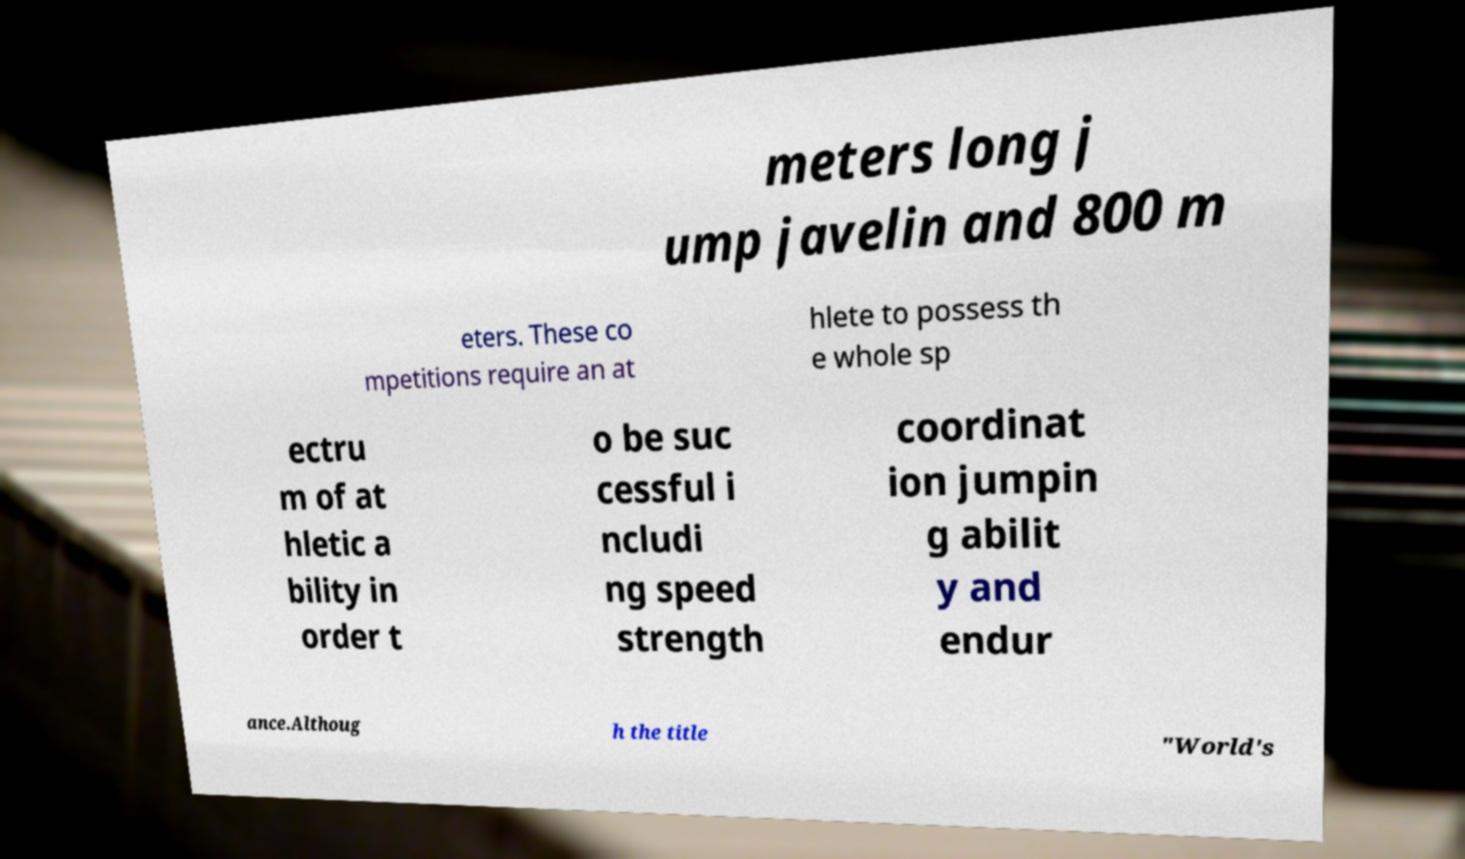Please read and relay the text visible in this image. What does it say? meters long j ump javelin and 800 m eters. These co mpetitions require an at hlete to possess th e whole sp ectru m of at hletic a bility in order t o be suc cessful i ncludi ng speed strength coordinat ion jumpin g abilit y and endur ance.Althoug h the title "World's 